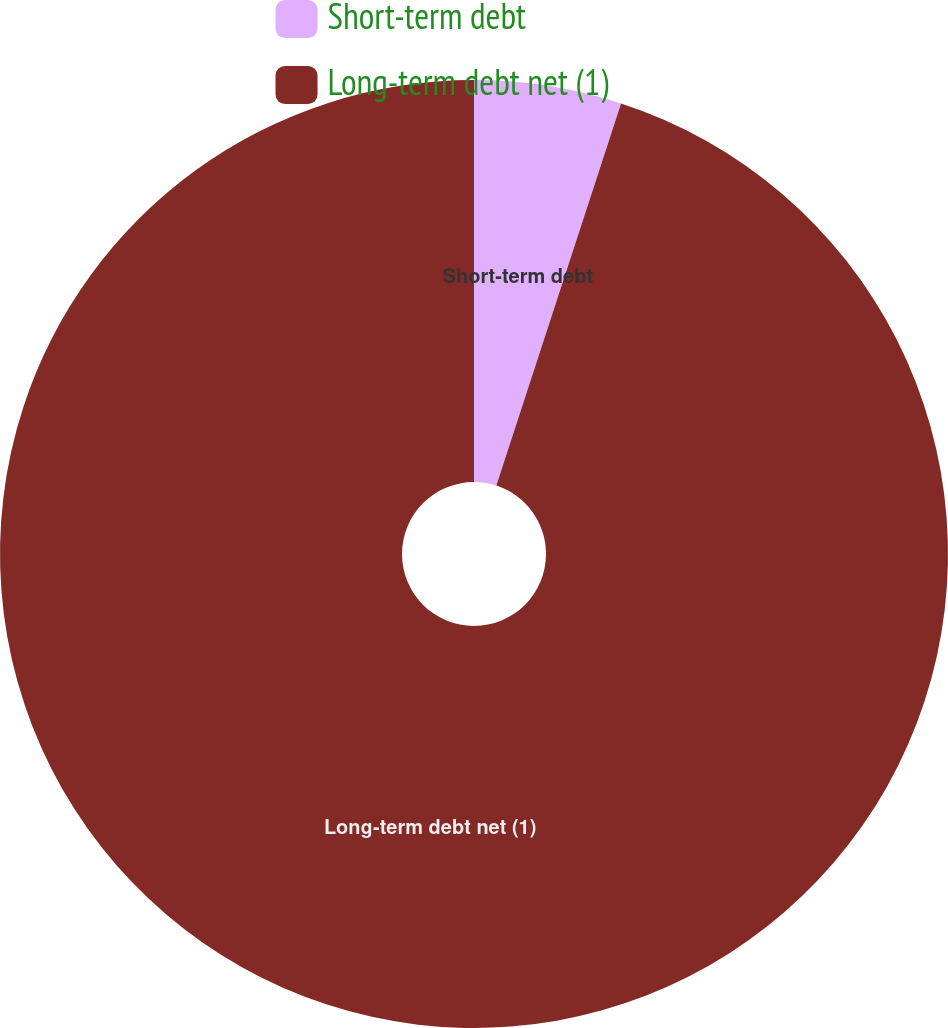Convert chart to OTSL. <chart><loc_0><loc_0><loc_500><loc_500><pie_chart><fcel>Short-term debt<fcel>Long-term debt net (1)<nl><fcel>5.02%<fcel>94.98%<nl></chart> 